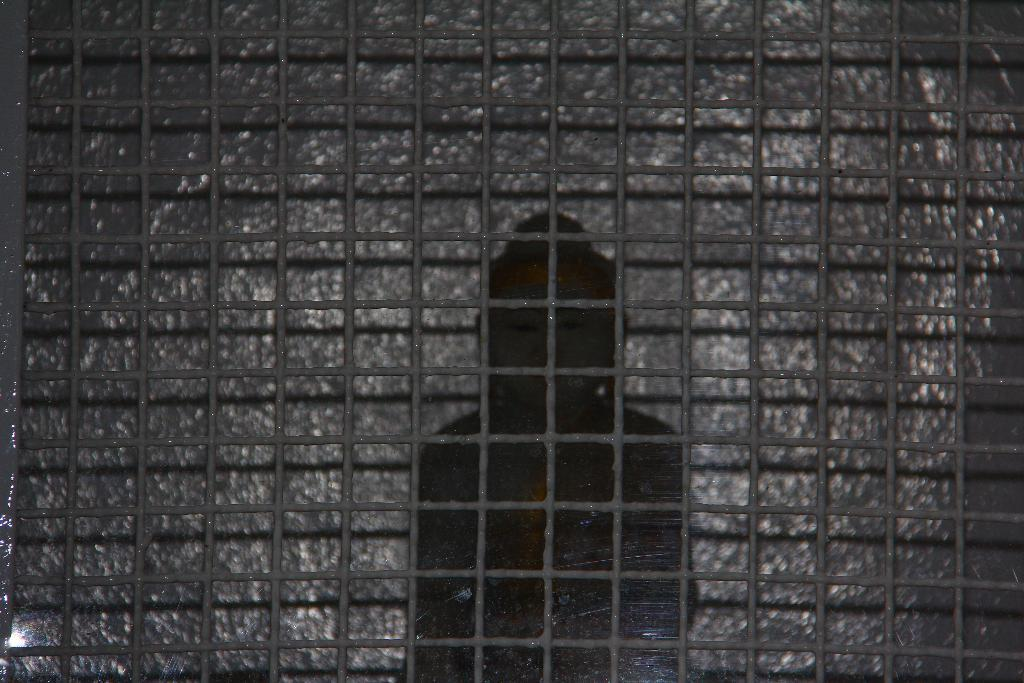What type of barrier can be seen in the image? There is a fence in the image. What other type of barrier is present in the image? There is a wall in the image. What type of drink is being served in the middle of the image? There is no drink or serving present in the image; it only features a fence and a wall. What type of thrill can be experienced by the fence in the image? The fence is an inanimate object and cannot experience thrills. 